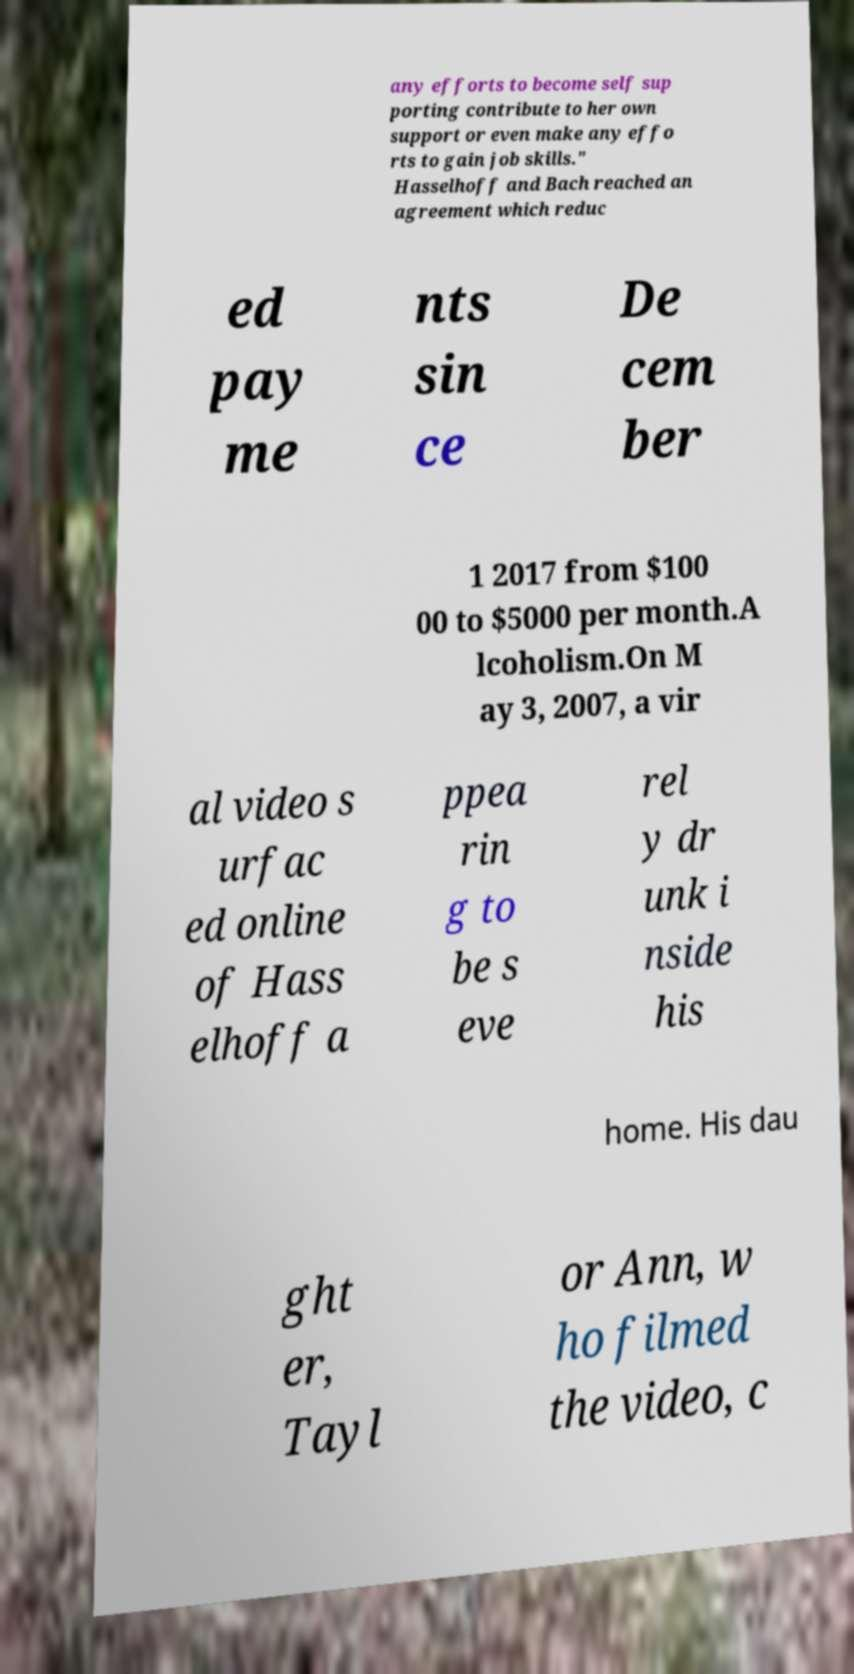For documentation purposes, I need the text within this image transcribed. Could you provide that? any efforts to become self sup porting contribute to her own support or even make any effo rts to gain job skills." Hasselhoff and Bach reached an agreement which reduc ed pay me nts sin ce De cem ber 1 2017 from $100 00 to $5000 per month.A lcoholism.On M ay 3, 2007, a vir al video s urfac ed online of Hass elhoff a ppea rin g to be s eve rel y dr unk i nside his home. His dau ght er, Tayl or Ann, w ho filmed the video, c 